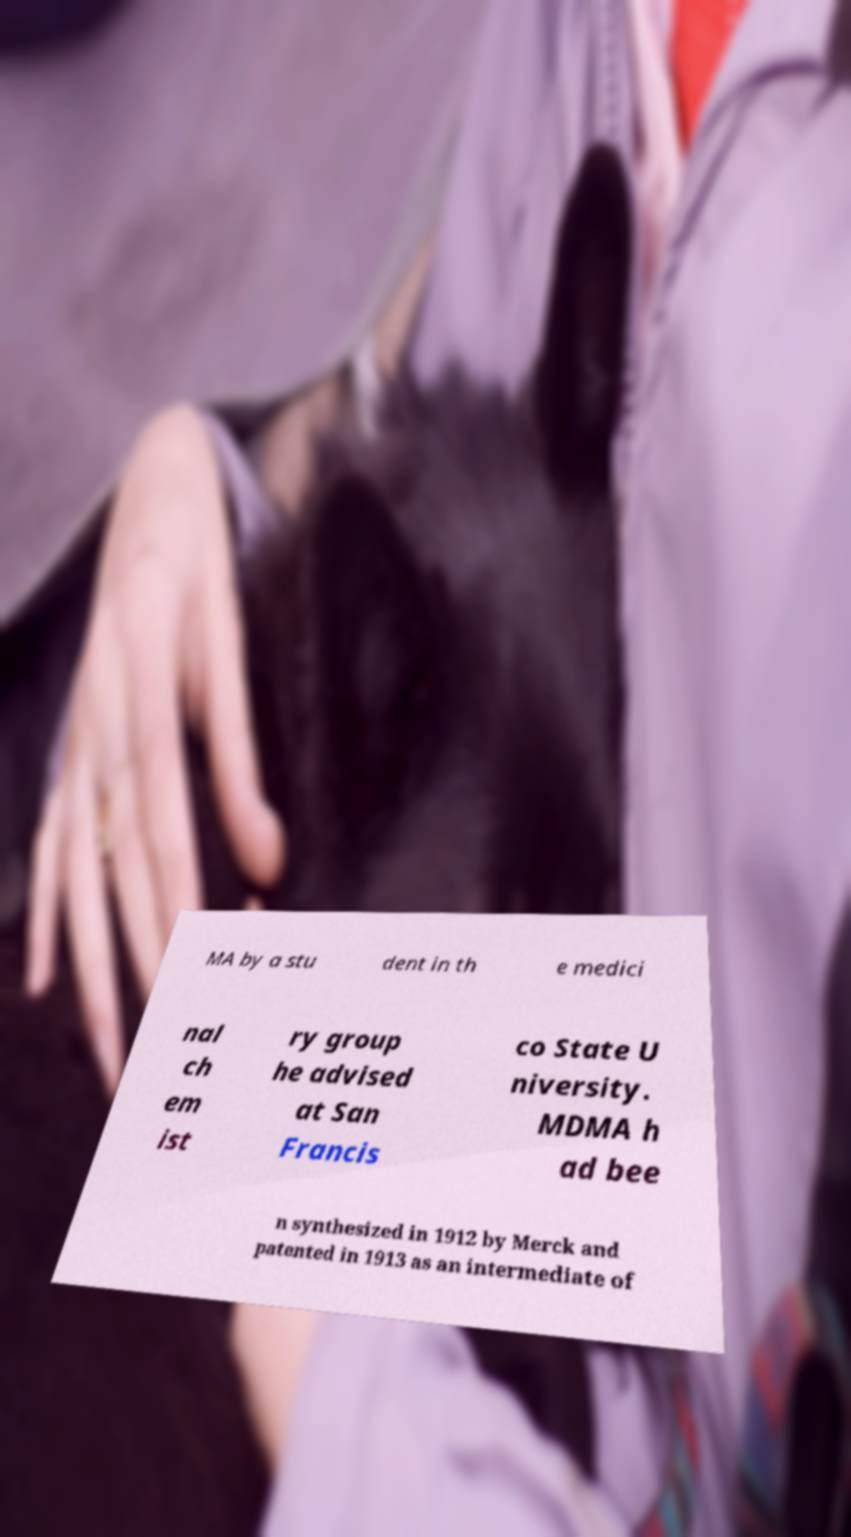Could you assist in decoding the text presented in this image and type it out clearly? MA by a stu dent in th e medici nal ch em ist ry group he advised at San Francis co State U niversity. MDMA h ad bee n synthesized in 1912 by Merck and patented in 1913 as an intermediate of 